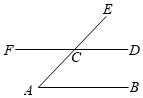First perform reasoning, then finally select the question from the choices in the following format: Answer: xxx.
Question: As shown in the diagram, AB is parallel to CD. AE intersects DF at point C, and angle ECF is equal to 134°. The degree measure of angle A is ()
Choices:
A: 54°
B: 46°
C: 45°
D: 44° Because angle ECD + angle ECF = 180°, and angle ECF = 134°, therefore angle ECD = 180° - angle ECF = 46°. Because AB is parallel to CD, therefore angle A = angle ECD = 46°. So the answer is: B.
Answer:B 